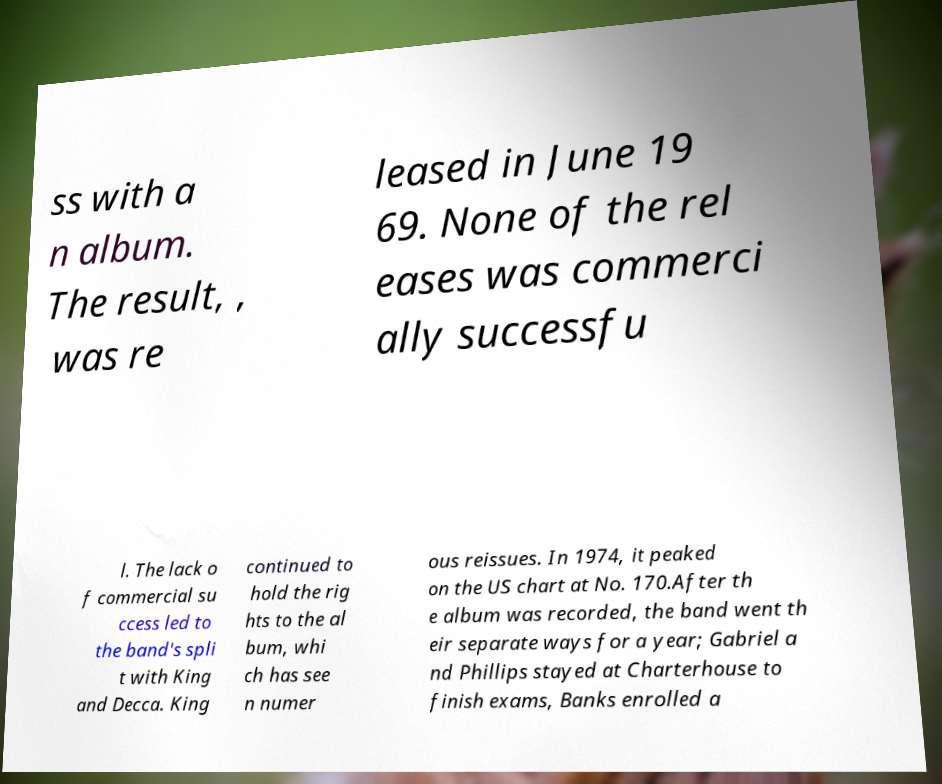Could you extract and type out the text from this image? ss with a n album. The result, , was re leased in June 19 69. None of the rel eases was commerci ally successfu l. The lack o f commercial su ccess led to the band's spli t with King and Decca. King continued to hold the rig hts to the al bum, whi ch has see n numer ous reissues. In 1974, it peaked on the US chart at No. 170.After th e album was recorded, the band went th eir separate ways for a year; Gabriel a nd Phillips stayed at Charterhouse to finish exams, Banks enrolled a 